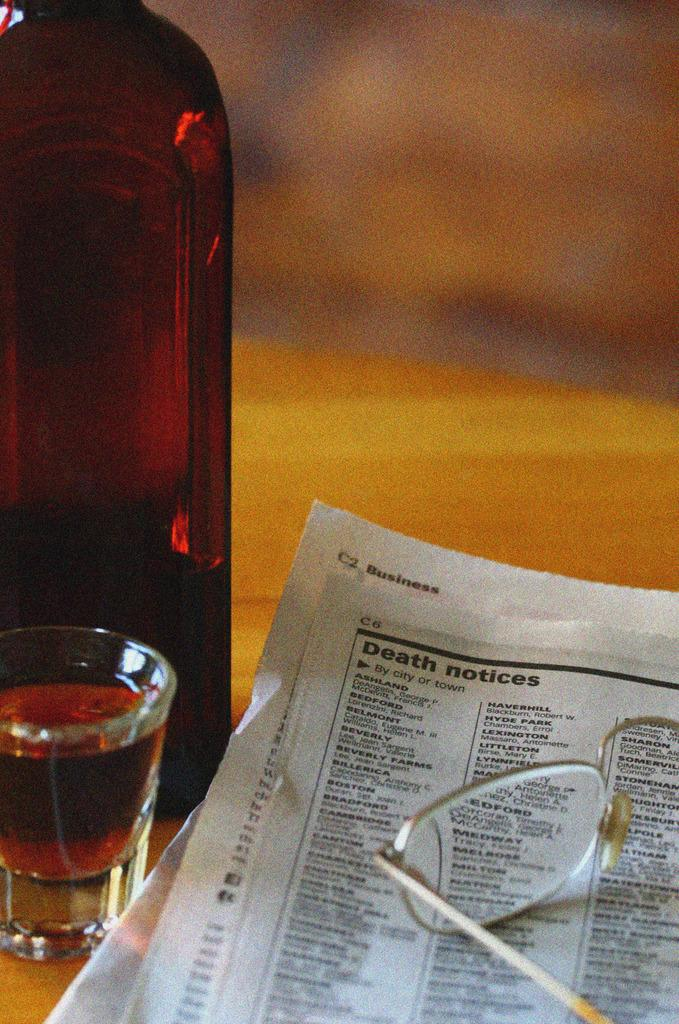<image>
Present a compact description of the photo's key features. A shot glass full of liquid sits beside the Obituaries in the paper with a set of glass frames on top. 